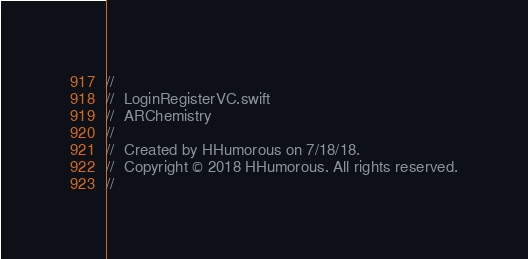Convert code to text. <code><loc_0><loc_0><loc_500><loc_500><_Swift_>//
//  LoginRegisterVC.swift
//  ARChemistry
//
//  Created by HHumorous on 7/18/18.
//  Copyright © 2018 HHumorous. All rights reserved.
//
</code> 